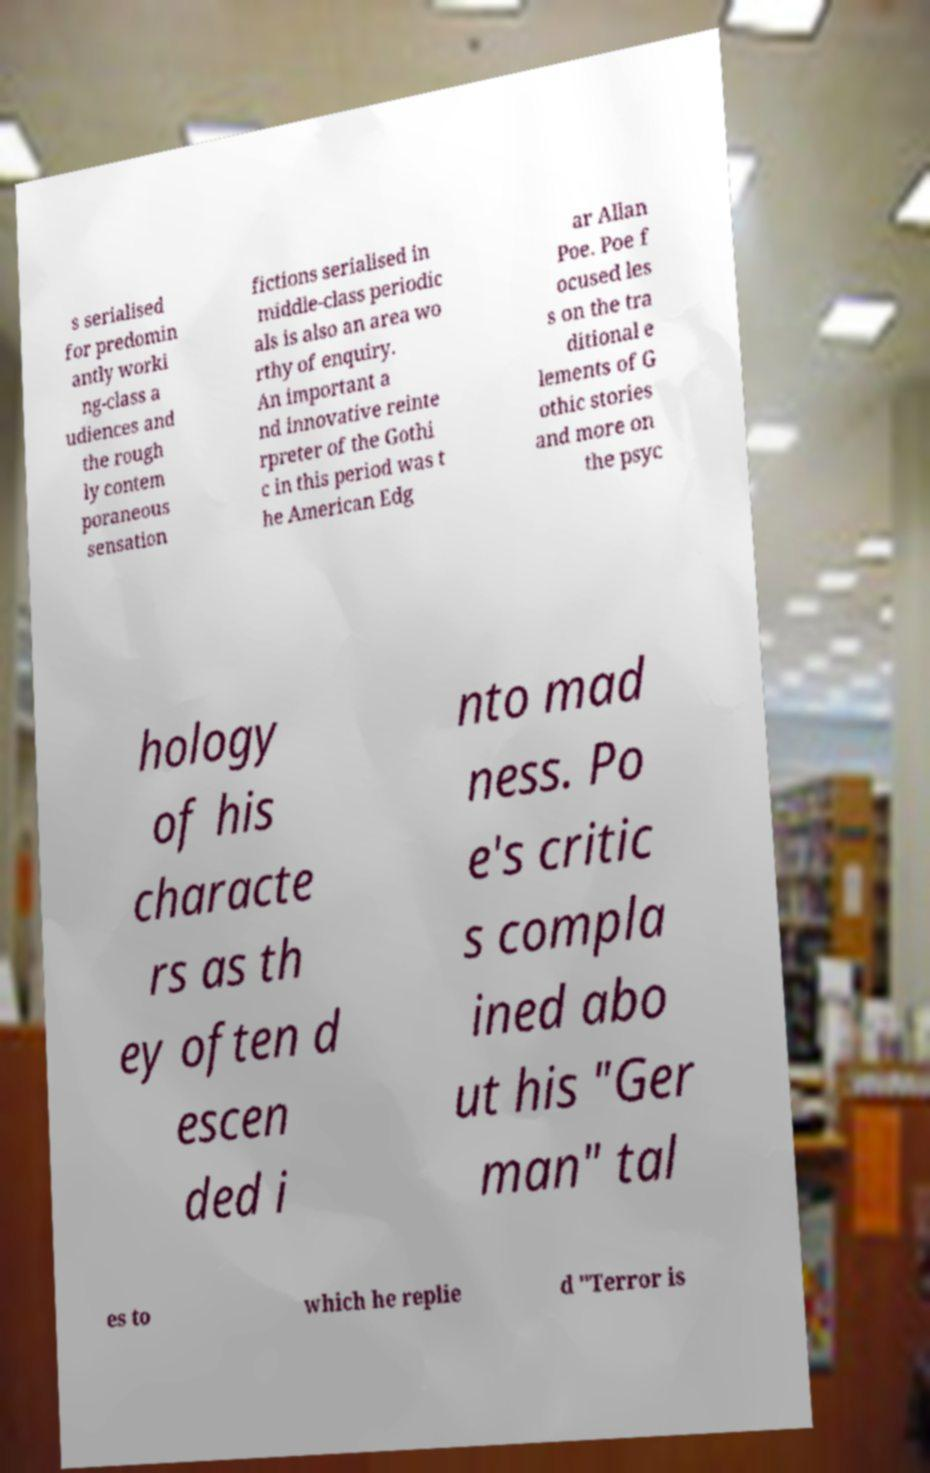There's text embedded in this image that I need extracted. Can you transcribe it verbatim? s serialised for predomin antly worki ng-class a udiences and the rough ly contem poraneous sensation fictions serialised in middle-class periodic als is also an area wo rthy of enquiry. An important a nd innovative reinte rpreter of the Gothi c in this period was t he American Edg ar Allan Poe. Poe f ocused les s on the tra ditional e lements of G othic stories and more on the psyc hology of his characte rs as th ey often d escen ded i nto mad ness. Po e's critic s compla ined abo ut his "Ger man" tal es to which he replie d "Terror is 